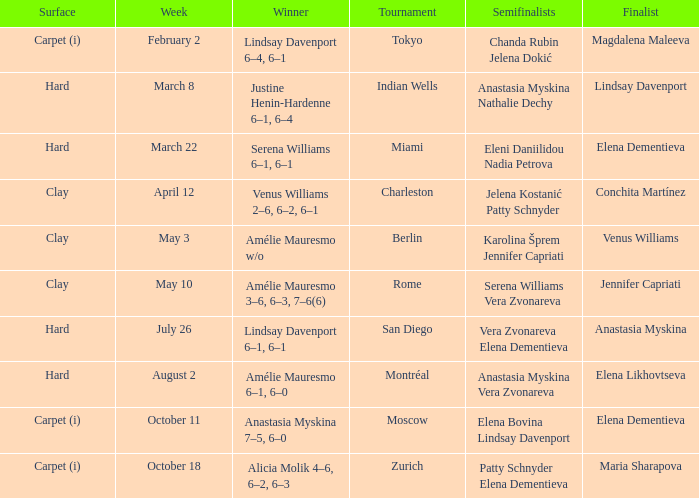Who was the winner of the Miami tournament where Elena Dementieva was a finalist? Serena Williams 6–1, 6–1. 